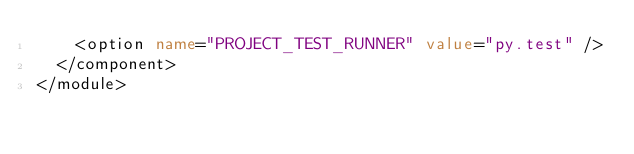<code> <loc_0><loc_0><loc_500><loc_500><_XML_>    <option name="PROJECT_TEST_RUNNER" value="py.test" />
  </component>
</module></code> 